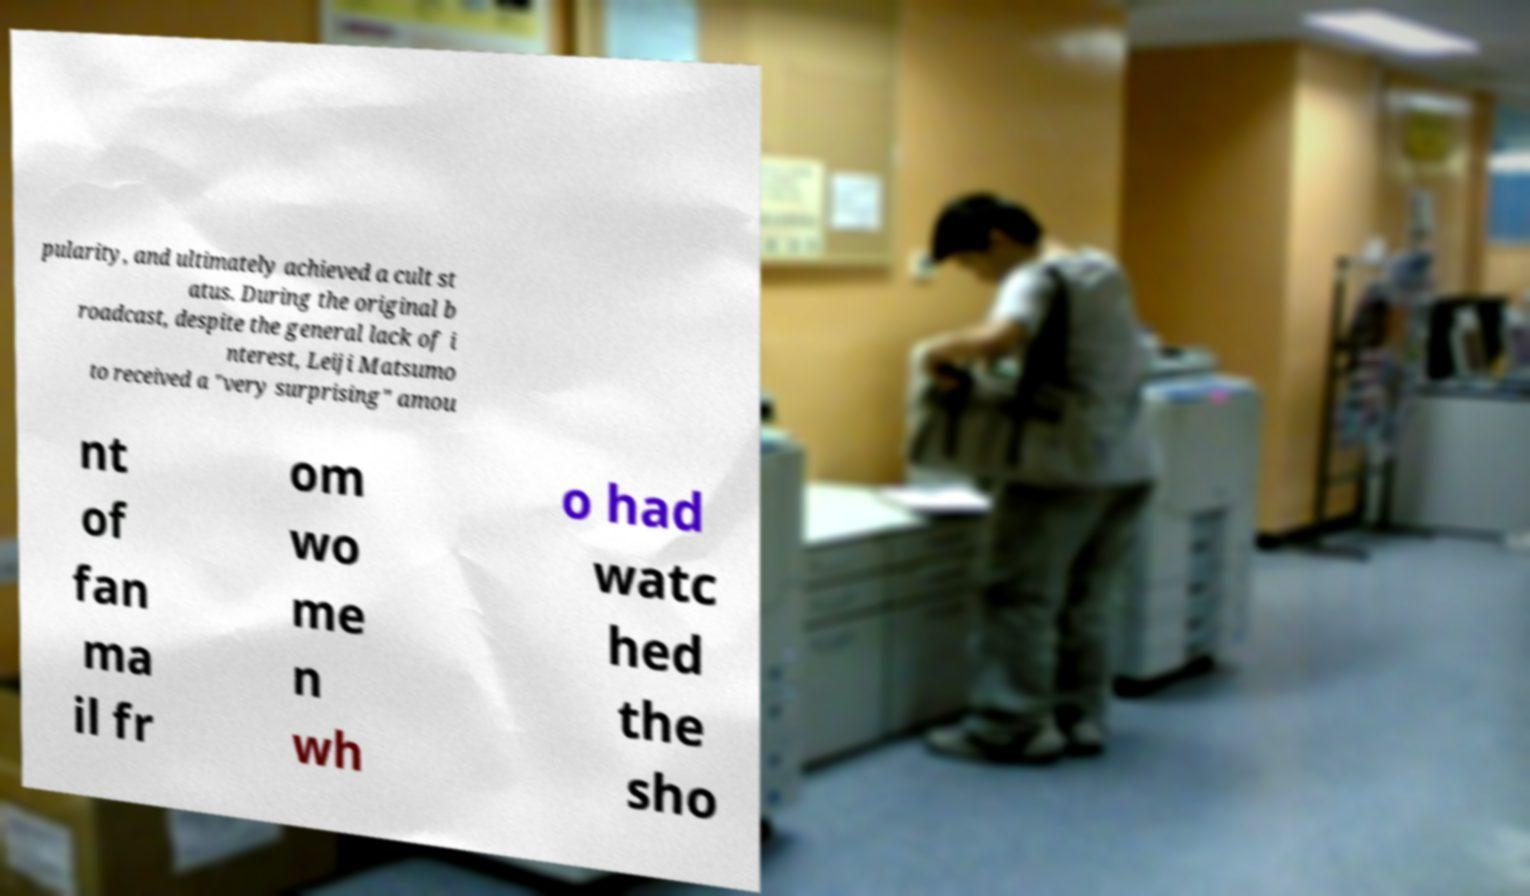What messages or text are displayed in this image? I need them in a readable, typed format. pularity, and ultimately achieved a cult st atus. During the original b roadcast, despite the general lack of i nterest, Leiji Matsumo to received a "very surprising" amou nt of fan ma il fr om wo me n wh o had watc hed the sho 